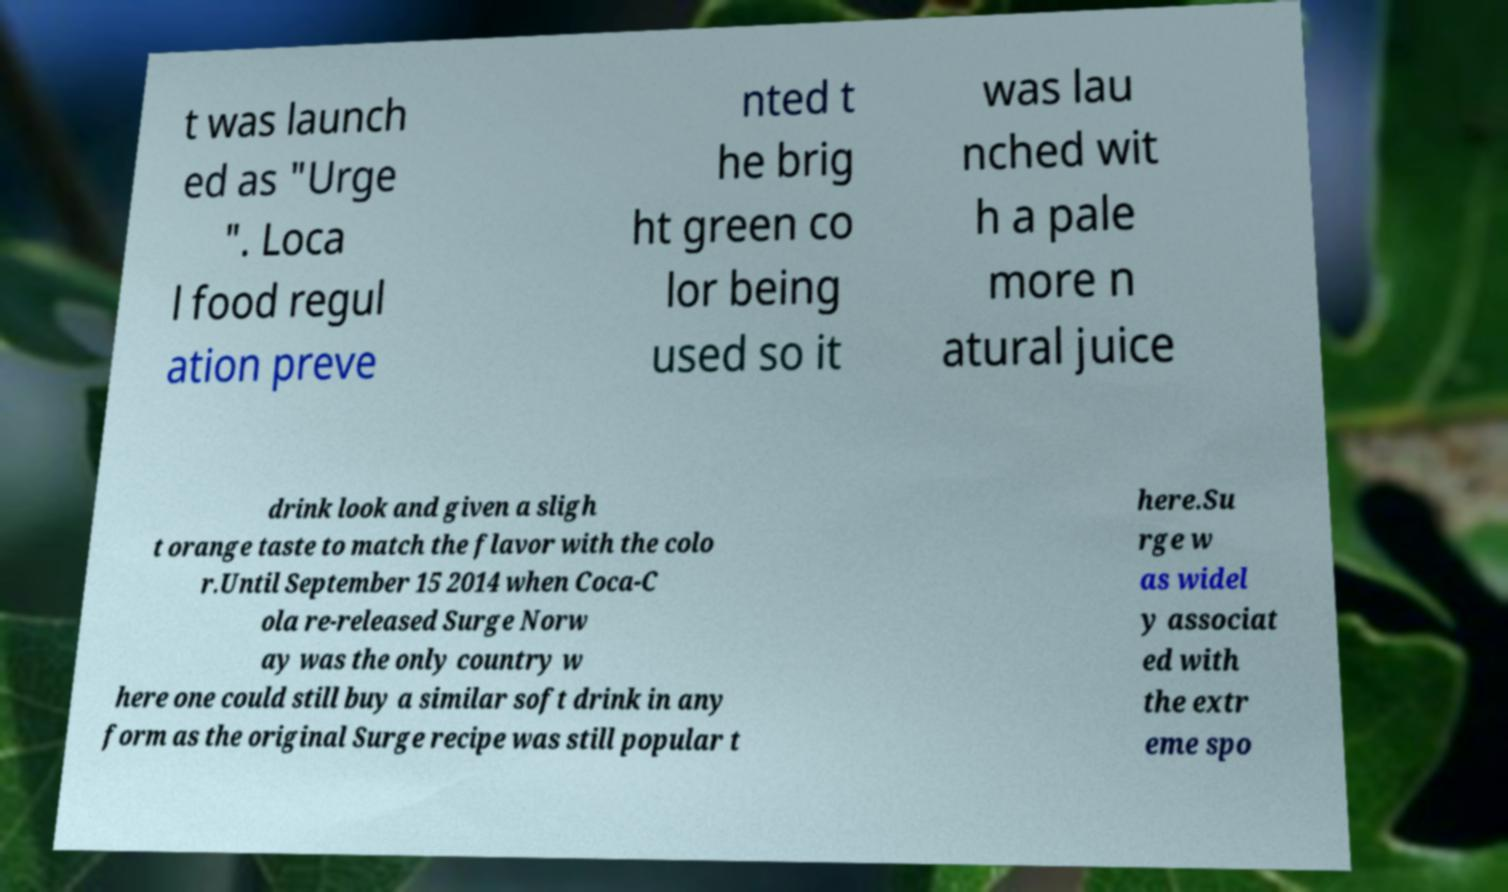Can you read and provide the text displayed in the image?This photo seems to have some interesting text. Can you extract and type it out for me? t was launch ed as "Urge ". Loca l food regul ation preve nted t he brig ht green co lor being used so it was lau nched wit h a pale more n atural juice drink look and given a sligh t orange taste to match the flavor with the colo r.Until September 15 2014 when Coca-C ola re-released Surge Norw ay was the only country w here one could still buy a similar soft drink in any form as the original Surge recipe was still popular t here.Su rge w as widel y associat ed with the extr eme spo 